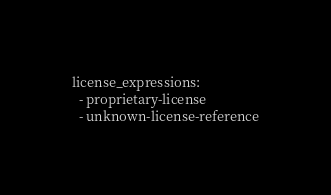Convert code to text. <code><loc_0><loc_0><loc_500><loc_500><_YAML_>license_expressions:
  - proprietary-license
  - unknown-license-reference
</code> 